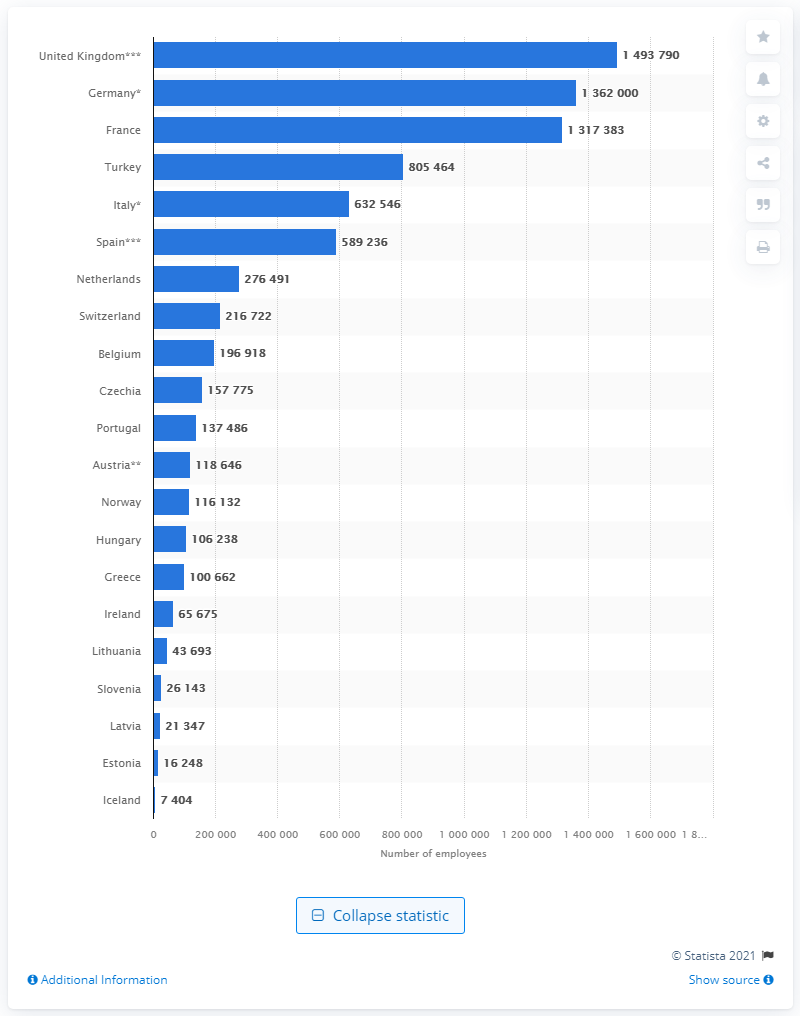Specify some key components in this picture. In 2018, there were 1,493,790 people employed in hospitals in the UK. 